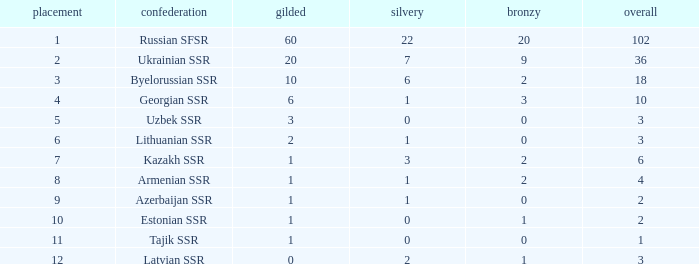What is the complete sum of bronzes related to 1 silver, standings below 6, and under 6 golds? None. 